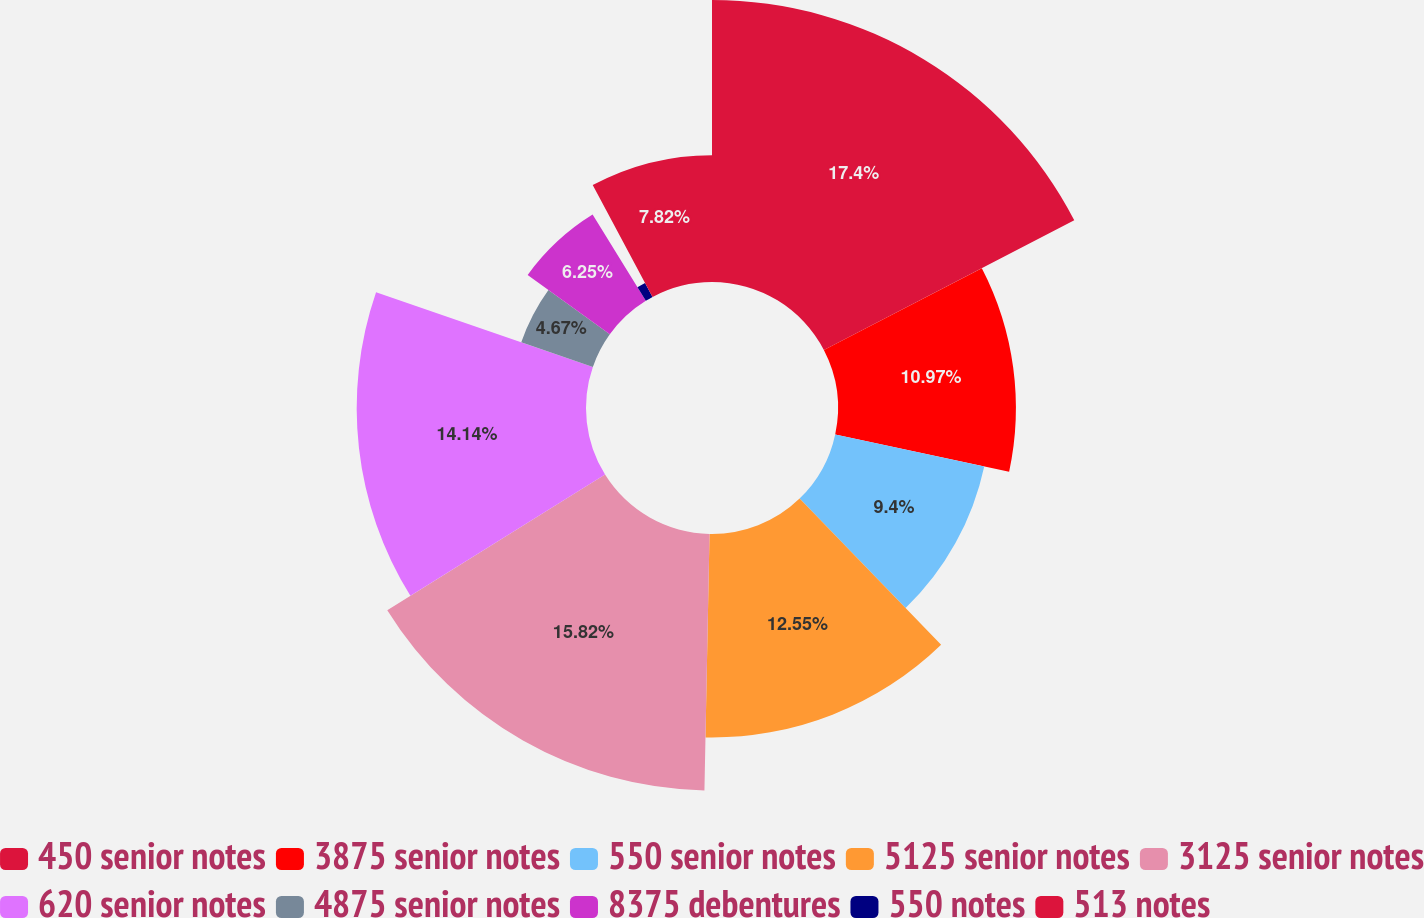<chart> <loc_0><loc_0><loc_500><loc_500><pie_chart><fcel>450 senior notes<fcel>3875 senior notes<fcel>550 senior notes<fcel>5125 senior notes<fcel>3125 senior notes<fcel>620 senior notes<fcel>4875 senior notes<fcel>8375 debentures<fcel>550 notes<fcel>513 notes<nl><fcel>17.39%<fcel>10.97%<fcel>9.4%<fcel>12.55%<fcel>15.82%<fcel>14.14%<fcel>4.67%<fcel>6.25%<fcel>0.98%<fcel>7.82%<nl></chart> 